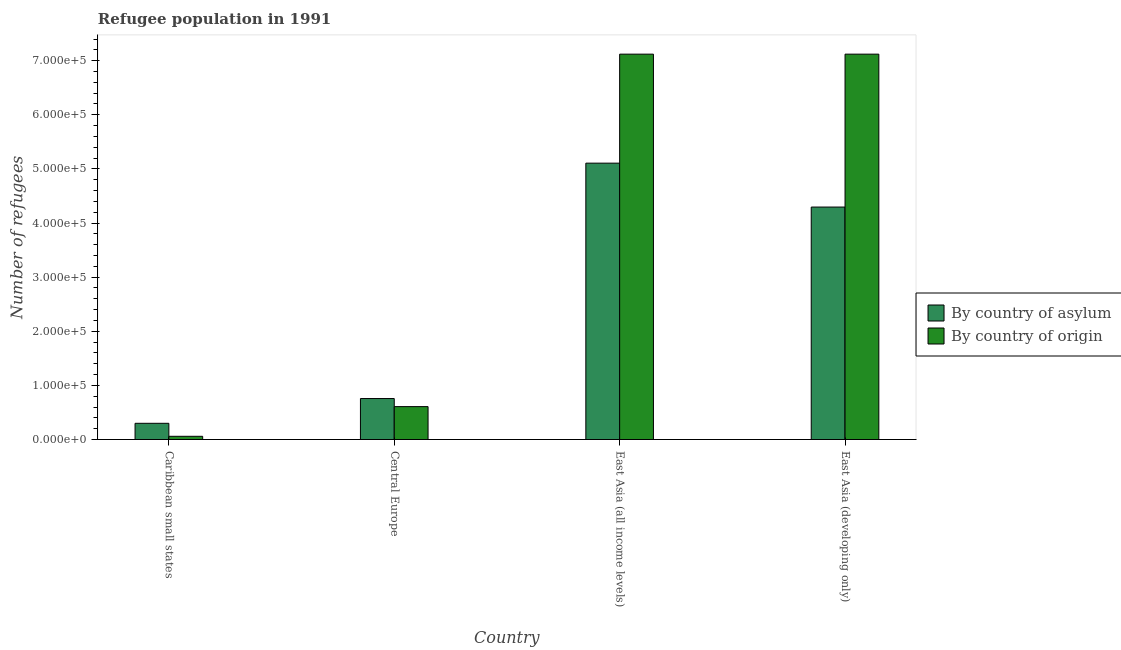How many different coloured bars are there?
Give a very brief answer. 2. How many groups of bars are there?
Keep it short and to the point. 4. How many bars are there on the 4th tick from the left?
Keep it short and to the point. 2. How many bars are there on the 4th tick from the right?
Offer a very short reply. 2. What is the label of the 1st group of bars from the left?
Provide a succinct answer. Caribbean small states. What is the number of refugees by country of origin in East Asia (developing only)?
Your response must be concise. 7.12e+05. Across all countries, what is the maximum number of refugees by country of origin?
Keep it short and to the point. 7.12e+05. Across all countries, what is the minimum number of refugees by country of asylum?
Provide a short and direct response. 3.00e+04. In which country was the number of refugees by country of asylum maximum?
Give a very brief answer. East Asia (all income levels). In which country was the number of refugees by country of origin minimum?
Give a very brief answer. Caribbean small states. What is the total number of refugees by country of asylum in the graph?
Your answer should be compact. 1.05e+06. What is the difference between the number of refugees by country of origin in East Asia (all income levels) and that in East Asia (developing only)?
Your response must be concise. 5. What is the difference between the number of refugees by country of origin in East Asia (all income levels) and the number of refugees by country of asylum in Caribbean small states?
Offer a terse response. 6.82e+05. What is the average number of refugees by country of asylum per country?
Your answer should be very brief. 2.61e+05. What is the difference between the number of refugees by country of origin and number of refugees by country of asylum in East Asia (developing only)?
Your answer should be very brief. 2.83e+05. What is the ratio of the number of refugees by country of asylum in Caribbean small states to that in East Asia (developing only)?
Offer a very short reply. 0.07. Is the difference between the number of refugees by country of origin in Caribbean small states and East Asia (all income levels) greater than the difference between the number of refugees by country of asylum in Caribbean small states and East Asia (all income levels)?
Your answer should be very brief. No. What is the difference between the highest and the second highest number of refugees by country of origin?
Your answer should be very brief. 5. What is the difference between the highest and the lowest number of refugees by country of asylum?
Provide a succinct answer. 4.81e+05. In how many countries, is the number of refugees by country of asylum greater than the average number of refugees by country of asylum taken over all countries?
Make the answer very short. 2. Is the sum of the number of refugees by country of origin in Central Europe and East Asia (all income levels) greater than the maximum number of refugees by country of asylum across all countries?
Ensure brevity in your answer.  Yes. What does the 2nd bar from the left in East Asia (developing only) represents?
Give a very brief answer. By country of origin. What does the 1st bar from the right in East Asia (developing only) represents?
Your answer should be very brief. By country of origin. Are all the bars in the graph horizontal?
Offer a very short reply. No. What is the difference between two consecutive major ticks on the Y-axis?
Your response must be concise. 1.00e+05. Are the values on the major ticks of Y-axis written in scientific E-notation?
Provide a succinct answer. Yes. Does the graph contain any zero values?
Offer a terse response. No. Where does the legend appear in the graph?
Provide a succinct answer. Center right. How are the legend labels stacked?
Keep it short and to the point. Vertical. What is the title of the graph?
Offer a terse response. Refugee population in 1991. Does "From production" appear as one of the legend labels in the graph?
Make the answer very short. No. What is the label or title of the X-axis?
Offer a terse response. Country. What is the label or title of the Y-axis?
Make the answer very short. Number of refugees. What is the Number of refugees of By country of asylum in Caribbean small states?
Give a very brief answer. 3.00e+04. What is the Number of refugees in By country of origin in Caribbean small states?
Your answer should be compact. 5927. What is the Number of refugees in By country of asylum in Central Europe?
Your response must be concise. 7.57e+04. What is the Number of refugees of By country of origin in Central Europe?
Provide a short and direct response. 6.08e+04. What is the Number of refugees of By country of asylum in East Asia (all income levels)?
Offer a terse response. 5.11e+05. What is the Number of refugees in By country of origin in East Asia (all income levels)?
Offer a terse response. 7.12e+05. What is the Number of refugees in By country of asylum in East Asia (developing only)?
Your answer should be compact. 4.30e+05. What is the Number of refugees in By country of origin in East Asia (developing only)?
Ensure brevity in your answer.  7.12e+05. Across all countries, what is the maximum Number of refugees of By country of asylum?
Ensure brevity in your answer.  5.11e+05. Across all countries, what is the maximum Number of refugees in By country of origin?
Ensure brevity in your answer.  7.12e+05. Across all countries, what is the minimum Number of refugees in By country of asylum?
Offer a very short reply. 3.00e+04. Across all countries, what is the minimum Number of refugees in By country of origin?
Your answer should be very brief. 5927. What is the total Number of refugees of By country of asylum in the graph?
Provide a short and direct response. 1.05e+06. What is the total Number of refugees in By country of origin in the graph?
Your answer should be very brief. 1.49e+06. What is the difference between the Number of refugees of By country of asylum in Caribbean small states and that in Central Europe?
Ensure brevity in your answer.  -4.58e+04. What is the difference between the Number of refugees in By country of origin in Caribbean small states and that in Central Europe?
Offer a terse response. -5.49e+04. What is the difference between the Number of refugees of By country of asylum in Caribbean small states and that in East Asia (all income levels)?
Provide a succinct answer. -4.81e+05. What is the difference between the Number of refugees of By country of origin in Caribbean small states and that in East Asia (all income levels)?
Offer a very short reply. -7.06e+05. What is the difference between the Number of refugees in By country of asylum in Caribbean small states and that in East Asia (developing only)?
Provide a short and direct response. -4.00e+05. What is the difference between the Number of refugees in By country of origin in Caribbean small states and that in East Asia (developing only)?
Your response must be concise. -7.06e+05. What is the difference between the Number of refugees of By country of asylum in Central Europe and that in East Asia (all income levels)?
Keep it short and to the point. -4.35e+05. What is the difference between the Number of refugees of By country of origin in Central Europe and that in East Asia (all income levels)?
Ensure brevity in your answer.  -6.51e+05. What is the difference between the Number of refugees in By country of asylum in Central Europe and that in East Asia (developing only)?
Your answer should be very brief. -3.54e+05. What is the difference between the Number of refugees of By country of origin in Central Europe and that in East Asia (developing only)?
Provide a short and direct response. -6.51e+05. What is the difference between the Number of refugees of By country of asylum in East Asia (all income levels) and that in East Asia (developing only)?
Your response must be concise. 8.11e+04. What is the difference between the Number of refugees in By country of origin in East Asia (all income levels) and that in East Asia (developing only)?
Provide a succinct answer. 5. What is the difference between the Number of refugees of By country of asylum in Caribbean small states and the Number of refugees of By country of origin in Central Europe?
Provide a short and direct response. -3.08e+04. What is the difference between the Number of refugees of By country of asylum in Caribbean small states and the Number of refugees of By country of origin in East Asia (all income levels)?
Your response must be concise. -6.82e+05. What is the difference between the Number of refugees in By country of asylum in Caribbean small states and the Number of refugees in By country of origin in East Asia (developing only)?
Make the answer very short. -6.82e+05. What is the difference between the Number of refugees of By country of asylum in Central Europe and the Number of refugees of By country of origin in East Asia (all income levels)?
Ensure brevity in your answer.  -6.36e+05. What is the difference between the Number of refugees in By country of asylum in Central Europe and the Number of refugees in By country of origin in East Asia (developing only)?
Your answer should be very brief. -6.36e+05. What is the difference between the Number of refugees in By country of asylum in East Asia (all income levels) and the Number of refugees in By country of origin in East Asia (developing only)?
Ensure brevity in your answer.  -2.01e+05. What is the average Number of refugees of By country of asylum per country?
Offer a terse response. 2.61e+05. What is the average Number of refugees of By country of origin per country?
Provide a short and direct response. 3.73e+05. What is the difference between the Number of refugees of By country of asylum and Number of refugees of By country of origin in Caribbean small states?
Offer a very short reply. 2.40e+04. What is the difference between the Number of refugees of By country of asylum and Number of refugees of By country of origin in Central Europe?
Your answer should be very brief. 1.49e+04. What is the difference between the Number of refugees in By country of asylum and Number of refugees in By country of origin in East Asia (all income levels)?
Offer a very short reply. -2.01e+05. What is the difference between the Number of refugees of By country of asylum and Number of refugees of By country of origin in East Asia (developing only)?
Your answer should be compact. -2.83e+05. What is the ratio of the Number of refugees in By country of asylum in Caribbean small states to that in Central Europe?
Provide a succinct answer. 0.4. What is the ratio of the Number of refugees in By country of origin in Caribbean small states to that in Central Europe?
Give a very brief answer. 0.1. What is the ratio of the Number of refugees of By country of asylum in Caribbean small states to that in East Asia (all income levels)?
Ensure brevity in your answer.  0.06. What is the ratio of the Number of refugees in By country of origin in Caribbean small states to that in East Asia (all income levels)?
Your response must be concise. 0.01. What is the ratio of the Number of refugees in By country of asylum in Caribbean small states to that in East Asia (developing only)?
Provide a succinct answer. 0.07. What is the ratio of the Number of refugees of By country of origin in Caribbean small states to that in East Asia (developing only)?
Your answer should be very brief. 0.01. What is the ratio of the Number of refugees of By country of asylum in Central Europe to that in East Asia (all income levels)?
Your response must be concise. 0.15. What is the ratio of the Number of refugees of By country of origin in Central Europe to that in East Asia (all income levels)?
Your answer should be very brief. 0.09. What is the ratio of the Number of refugees of By country of asylum in Central Europe to that in East Asia (developing only)?
Your answer should be compact. 0.18. What is the ratio of the Number of refugees in By country of origin in Central Europe to that in East Asia (developing only)?
Ensure brevity in your answer.  0.09. What is the ratio of the Number of refugees of By country of asylum in East Asia (all income levels) to that in East Asia (developing only)?
Keep it short and to the point. 1.19. What is the difference between the highest and the second highest Number of refugees in By country of asylum?
Offer a very short reply. 8.11e+04. What is the difference between the highest and the lowest Number of refugees in By country of asylum?
Give a very brief answer. 4.81e+05. What is the difference between the highest and the lowest Number of refugees in By country of origin?
Give a very brief answer. 7.06e+05. 